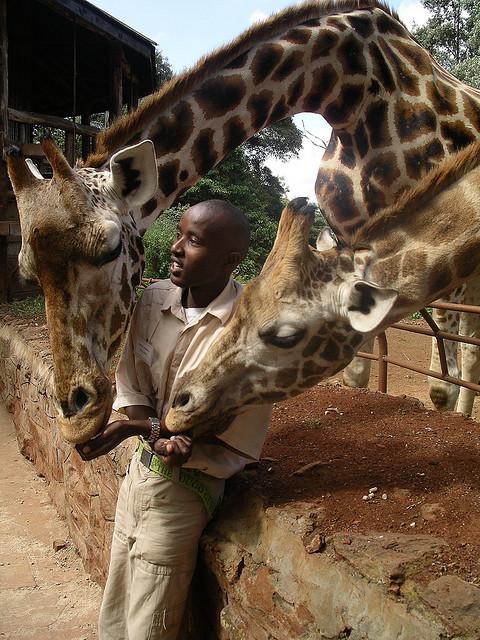Does this man look happy?
Answer briefly. Yes. How many giraffes are in this photo?
Quick response, please. 2. What is the man doing?
Short answer required. Feeding giraffes. 